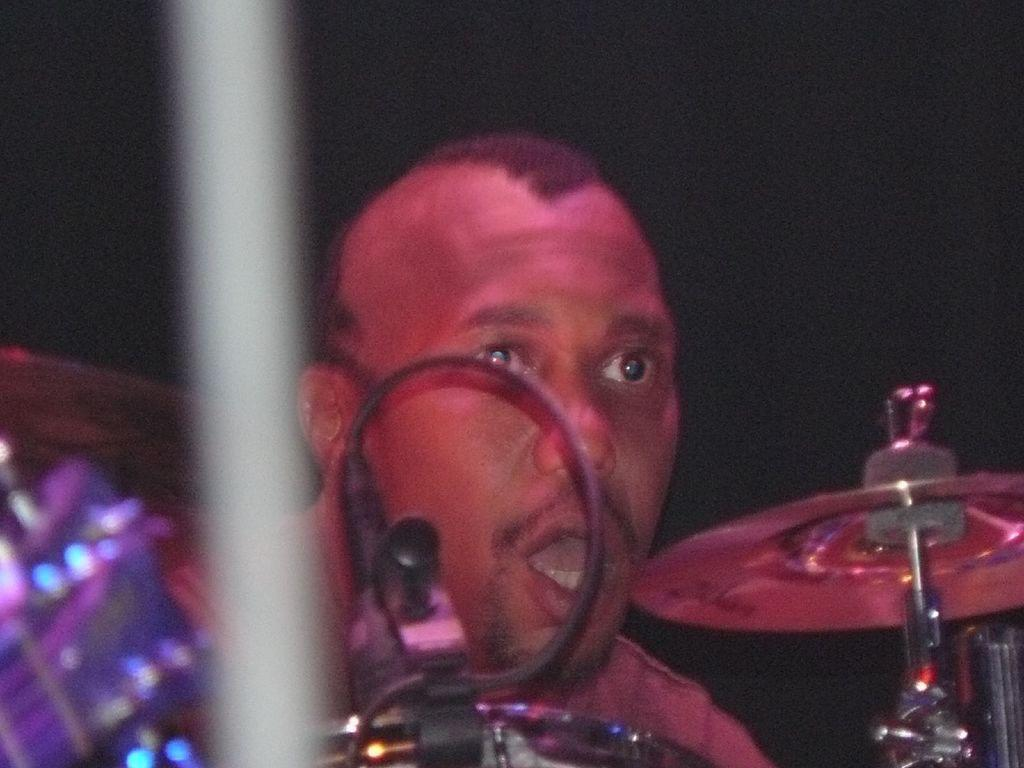What can be seen in the image that is related to communication or technology? There is a cable in the image. What else is present in the image that is related to an artistic or creative activity? There are musical instruments in the image. Can you describe the person in the image? There is a person in the image. What can be said about the lighting or color scheme of the image? The background of the image is dark. What type of health advice is the person in the image giving to the army? There is no army or health advice present in the image; it features a person and musical instruments. How many knots are tied in the cable in the image? There are no knots visible in the cable in the image; it appears to be a straight cable. 